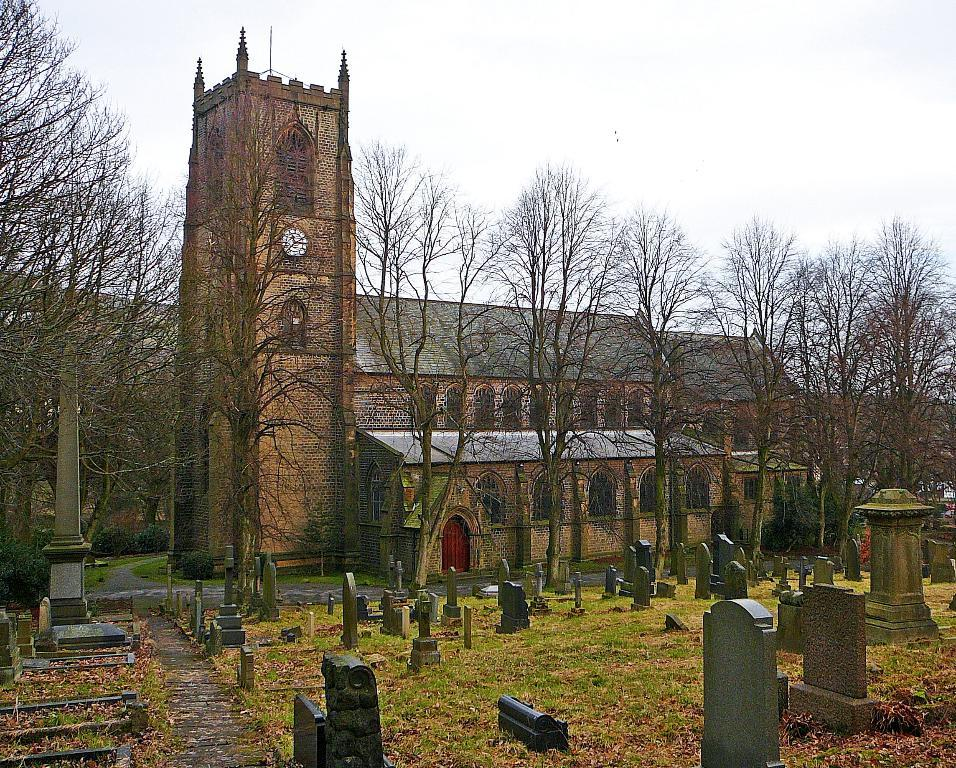What type of objects can be seen in the image? There are statues in the image. What is the surface on which the statues are placed? There is grass on the surface in the image. What can be seen in the background of the image? There are buildings, trees, and the sky visible in the background of the image. How many bulbs are hanging from the trees in the image? There are no bulbs present in the image; it features statues, grass, buildings, trees, and the sky. What type of structure can be seen in the image that is made of bears? There is no structure made of bears present in the image. 